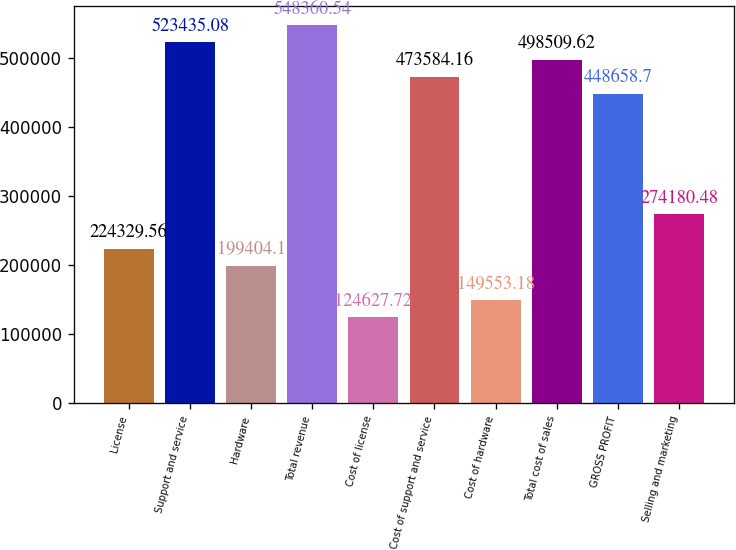<chart> <loc_0><loc_0><loc_500><loc_500><bar_chart><fcel>License<fcel>Support and service<fcel>Hardware<fcel>Total revenue<fcel>Cost of license<fcel>Cost of support and service<fcel>Cost of hardware<fcel>Total cost of sales<fcel>GROSS PROFIT<fcel>Selling and marketing<nl><fcel>224330<fcel>523435<fcel>199404<fcel>548361<fcel>124628<fcel>473584<fcel>149553<fcel>498510<fcel>448659<fcel>274180<nl></chart> 